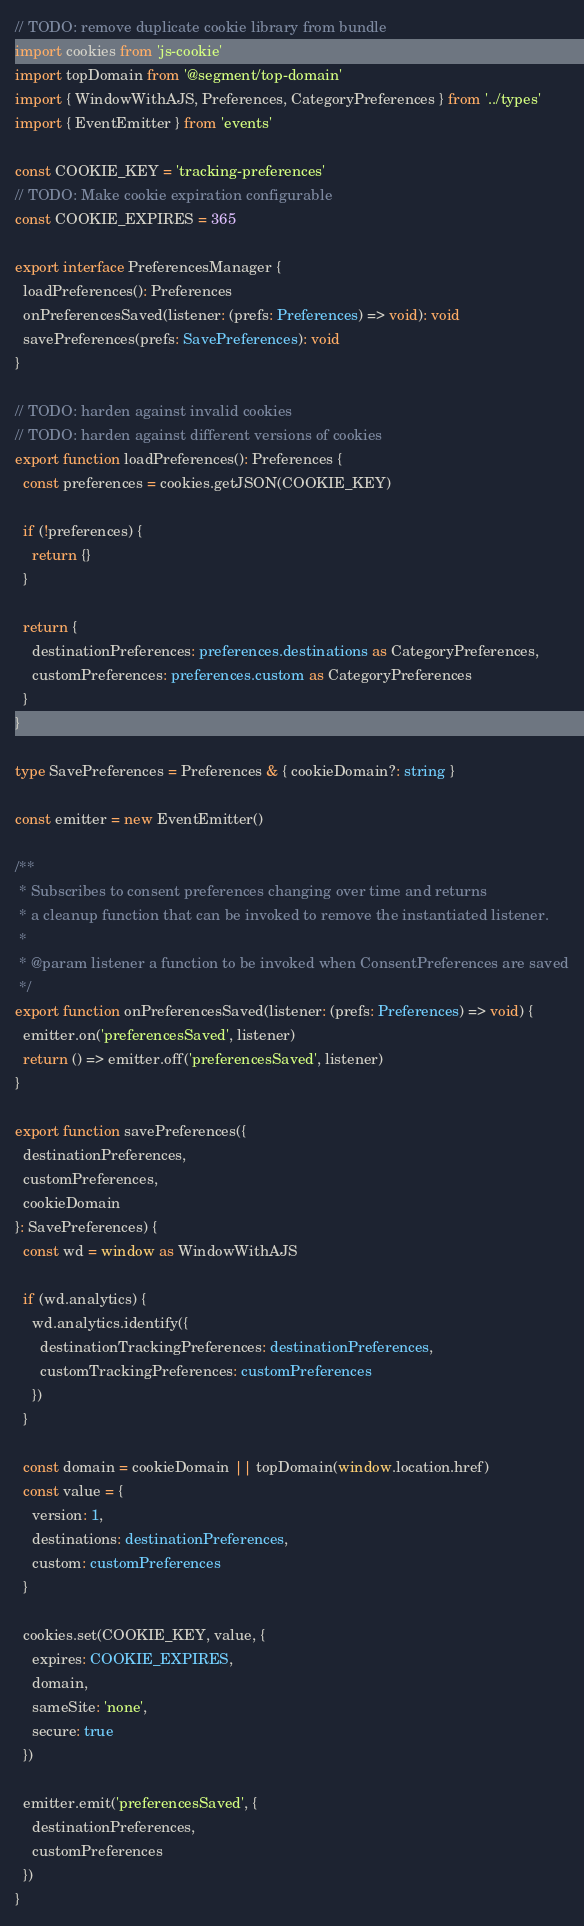<code> <loc_0><loc_0><loc_500><loc_500><_TypeScript_>// TODO: remove duplicate cookie library from bundle
import cookies from 'js-cookie'
import topDomain from '@segment/top-domain'
import { WindowWithAJS, Preferences, CategoryPreferences } from '../types'
import { EventEmitter } from 'events'

const COOKIE_KEY = 'tracking-preferences'
// TODO: Make cookie expiration configurable
const COOKIE_EXPIRES = 365

export interface PreferencesManager {
  loadPreferences(): Preferences
  onPreferencesSaved(listener: (prefs: Preferences) => void): void
  savePreferences(prefs: SavePreferences): void
}

// TODO: harden against invalid cookies
// TODO: harden against different versions of cookies
export function loadPreferences(): Preferences {
  const preferences = cookies.getJSON(COOKIE_KEY)

  if (!preferences) {
    return {}
  }

  return {
    destinationPreferences: preferences.destinations as CategoryPreferences,
    customPreferences: preferences.custom as CategoryPreferences
  }
}

type SavePreferences = Preferences & { cookieDomain?: string }

const emitter = new EventEmitter()

/**
 * Subscribes to consent preferences changing over time and returns
 * a cleanup function that can be invoked to remove the instantiated listener.
 *
 * @param listener a function to be invoked when ConsentPreferences are saved
 */
export function onPreferencesSaved(listener: (prefs: Preferences) => void) {
  emitter.on('preferencesSaved', listener)
  return () => emitter.off('preferencesSaved', listener)
}

export function savePreferences({
  destinationPreferences,
  customPreferences,
  cookieDomain
}: SavePreferences) {
  const wd = window as WindowWithAJS

  if (wd.analytics) {
    wd.analytics.identify({
      destinationTrackingPreferences: destinationPreferences,
      customTrackingPreferences: customPreferences
    })
  }

  const domain = cookieDomain || topDomain(window.location.href)
  const value = {
    version: 1,
    destinations: destinationPreferences,
    custom: customPreferences
  }

  cookies.set(COOKIE_KEY, value, {
    expires: COOKIE_EXPIRES,
    domain,
    sameSite: 'none',
    secure: true
  })

  emitter.emit('preferencesSaved', {
    destinationPreferences,
    customPreferences
  })
}
</code> 